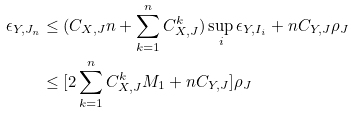Convert formula to latex. <formula><loc_0><loc_0><loc_500><loc_500>\epsilon _ { Y , J _ { n } } & \leq ( C _ { X , J } n + \sum _ { k = 1 } ^ { n } C _ { X , J } ^ { k } ) \sup _ { i } \epsilon _ { Y , I _ { i } } + n C _ { Y , J } \rho _ { J } \\ & \leq [ 2 \sum _ { k = 1 } ^ { n } C _ { X , J } ^ { k } M _ { 1 } + n C _ { Y , J } ] \rho _ { J }</formula> 